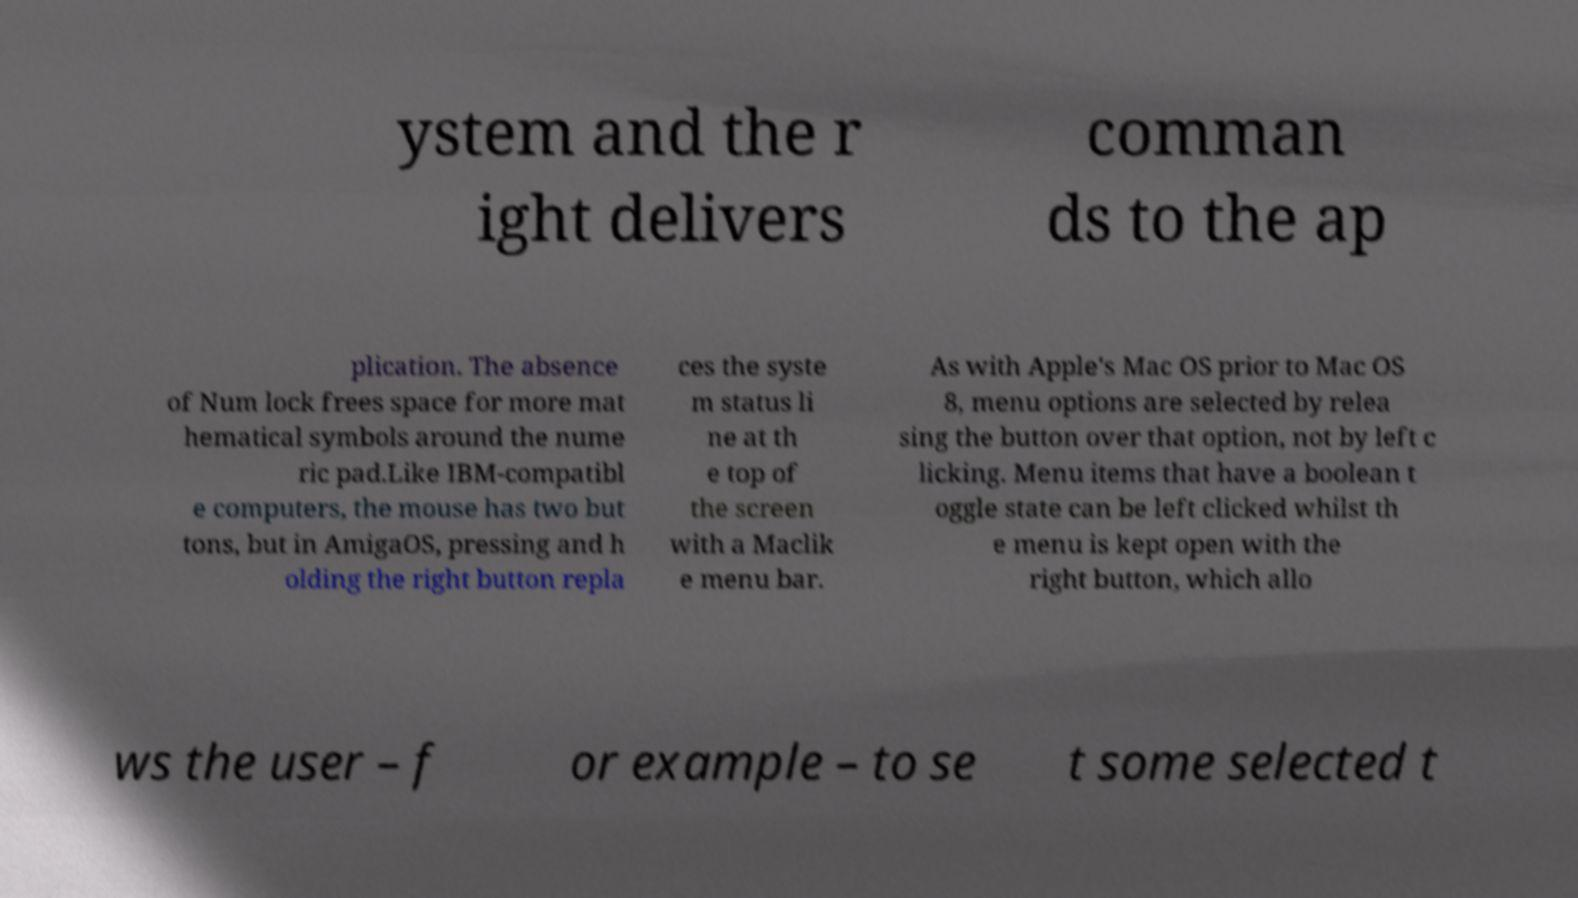There's text embedded in this image that I need extracted. Can you transcribe it verbatim? ystem and the r ight delivers comman ds to the ap plication. The absence of Num lock frees space for more mat hematical symbols around the nume ric pad.Like IBM-compatibl e computers, the mouse has two but tons, but in AmigaOS, pressing and h olding the right button repla ces the syste m status li ne at th e top of the screen with a Maclik e menu bar. As with Apple's Mac OS prior to Mac OS 8, menu options are selected by relea sing the button over that option, not by left c licking. Menu items that have a boolean t oggle state can be left clicked whilst th e menu is kept open with the right button, which allo ws the user – f or example – to se t some selected t 